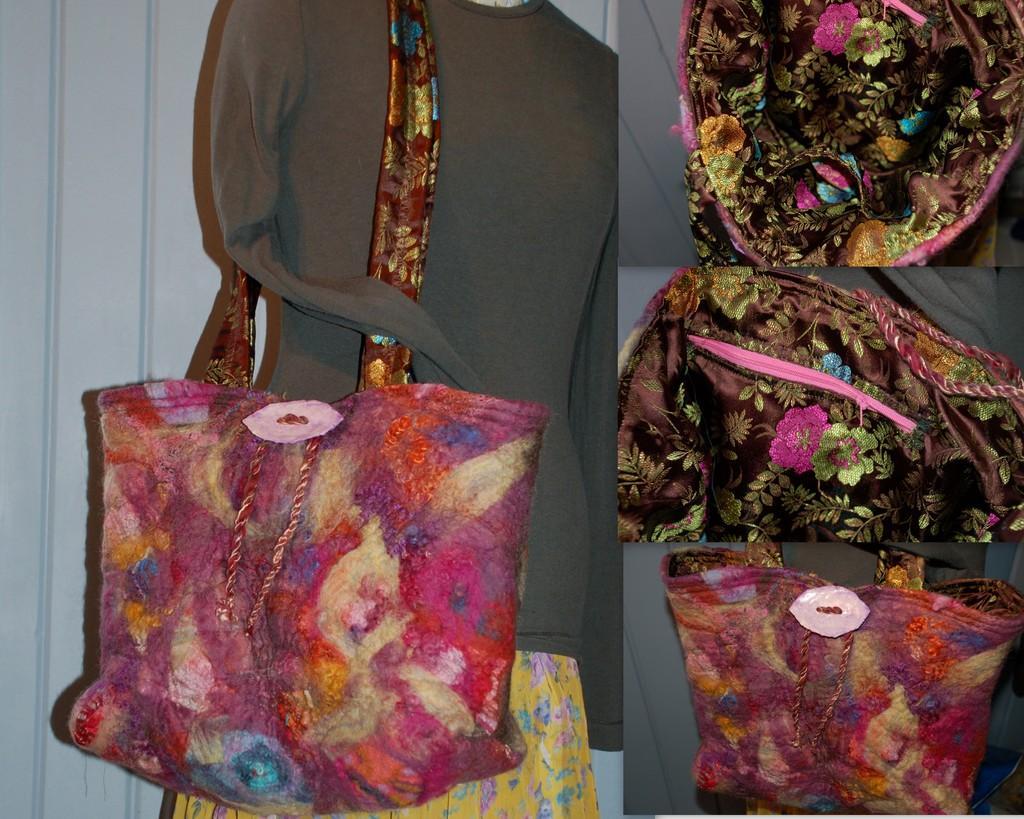Describe this image in one or two sentences. There is a pink hand bag which is attached to the dress of a women and there are similar handbags which are pink and brown in color. 